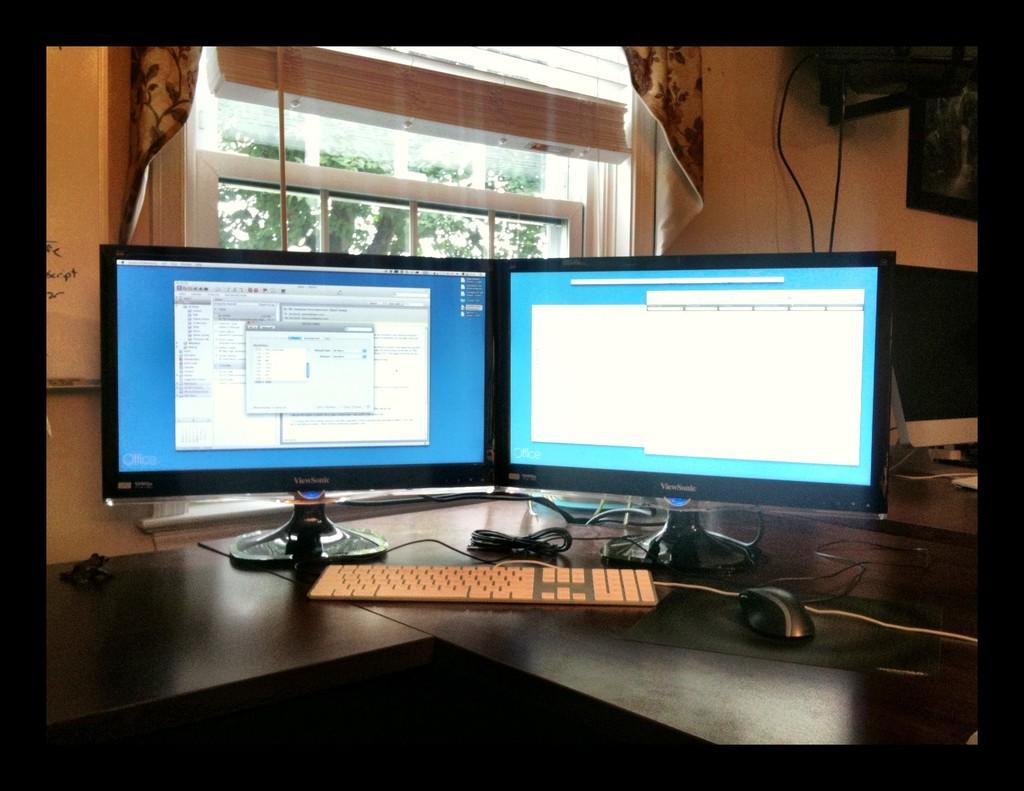What is the brand of the monitors?
Offer a terse response. Viewsonic. 